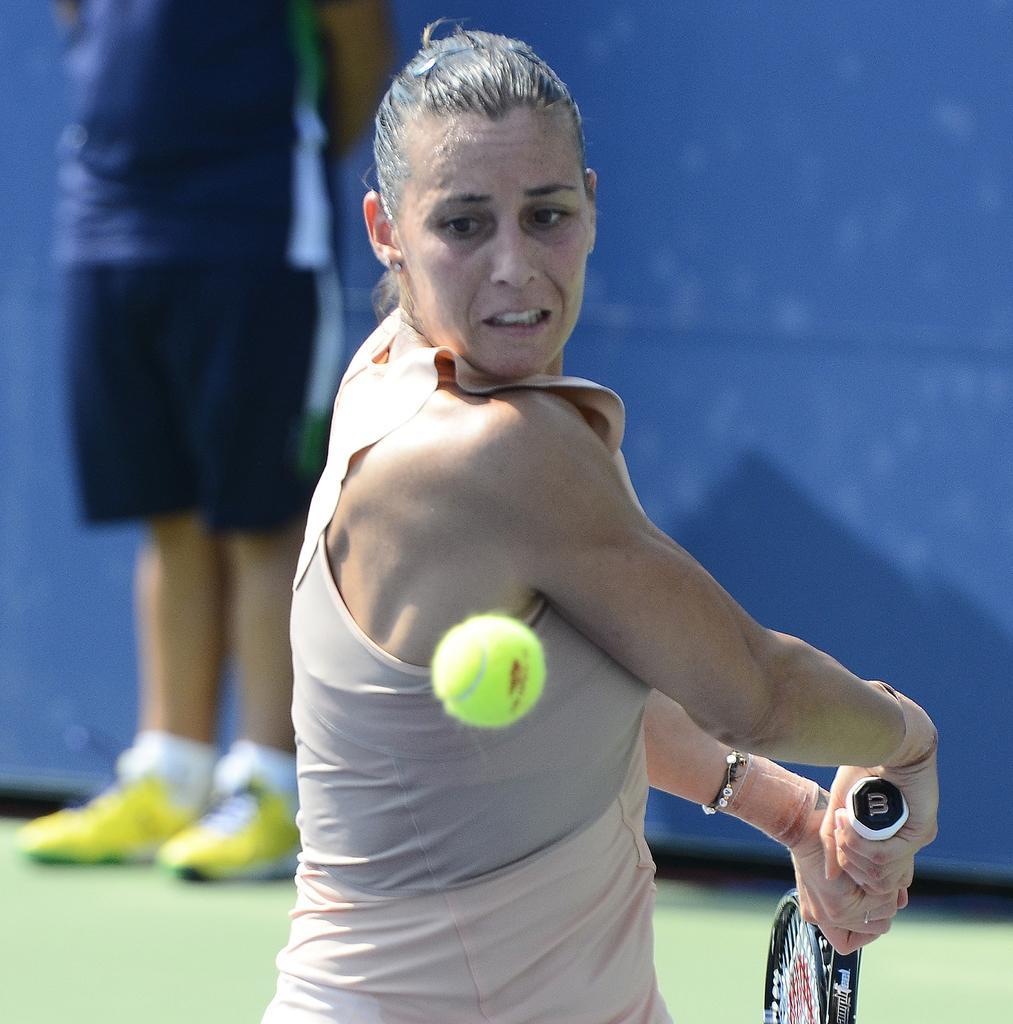How would you summarize this image in a sentence or two? In the image there is a woman in sleeveless top holding a tennis racket about to the ball and behind there is a person standing in front of the wall on the grass floor. 